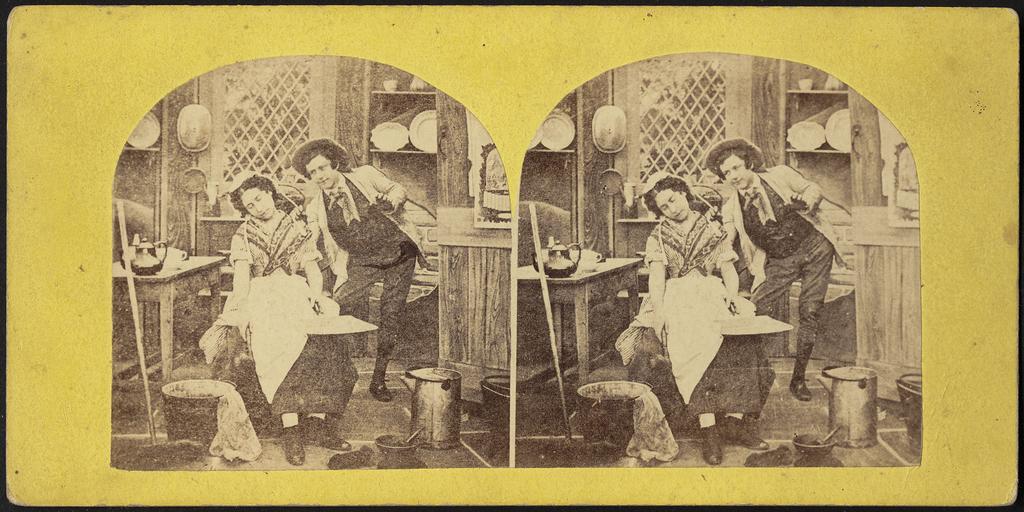How would you summarize this image in a sentence or two? In this image we can see a collage picture. In the picture we can see a man is standing and a woman is sitting in a chair. In the background we can see cupboards, wooden grill, table, kettle, bin and a mortar on the floor. 